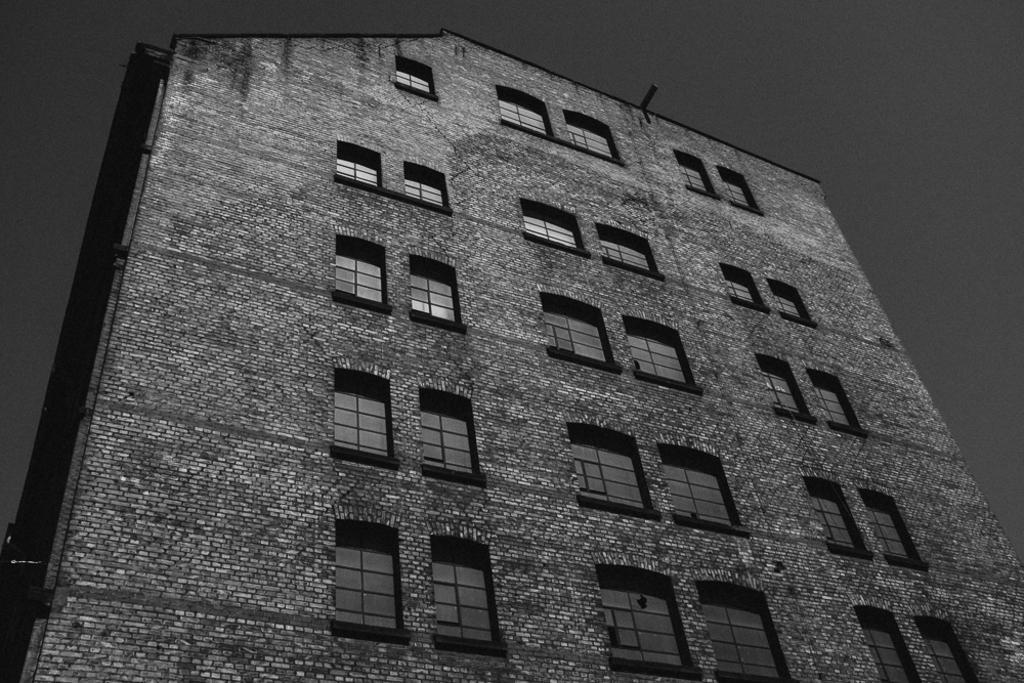Can you describe this image briefly? In this picture I can see the building. On the building I can see many windows. In the top right I can see the sky. 